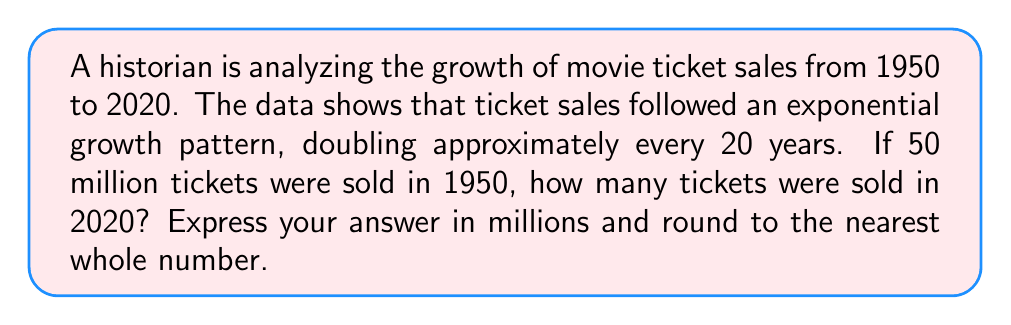Help me with this question. To solve this problem, we need to use the concept of exponential growth and determine how many times the ticket sales doubled between 1950 and 2020.

1. Calculate the number of 20-year periods between 1950 and 2020:
   $\frac{2020 - 1950}{20} = \frac{70}{20} = 3.5$ periods

2. The growth factor for each doubling period is 2. Since we have 3.5 periods, we need to calculate $2^{3.5}$.

3. To calculate $2^{3.5}$:
   $$2^{3.5} = 2^3 \times 2^{0.5} = 8 \times \sqrt{2} \approx 8 \times 1.4142 \approx 11.3137$$

4. Now, multiply the initial number of tickets by this growth factor:
   $$50 \text{ million} \times 11.3137 \approx 565.685 \text{ million}$$

5. Rounding to the nearest whole number:
   565.685 million ≈ 566 million

This analysis demonstrates how exponential growth can lead to significant increases over extended periods, which is relevant to understanding the cultural impact of the movie industry's expansion through the decades.
Answer: 566 million 